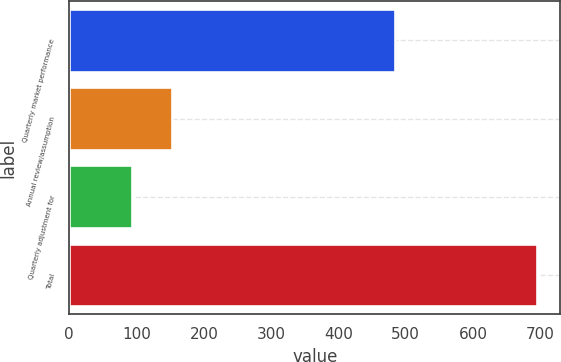Convert chart to OTSL. <chart><loc_0><loc_0><loc_500><loc_500><bar_chart><fcel>Quarterly market performance<fcel>Annual review/assumption<fcel>Quarterly adjustment for<fcel>Total<nl><fcel>484<fcel>153.2<fcel>93<fcel>695<nl></chart> 